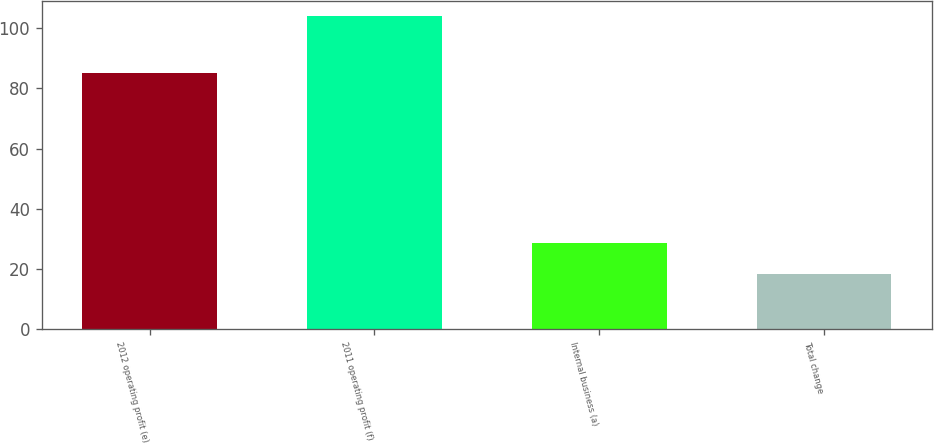<chart> <loc_0><loc_0><loc_500><loc_500><bar_chart><fcel>2012 operating profit (e)<fcel>2011 operating profit (f)<fcel>Internal business (a)<fcel>Total change<nl><fcel>85<fcel>104<fcel>28.7<fcel>18.4<nl></chart> 